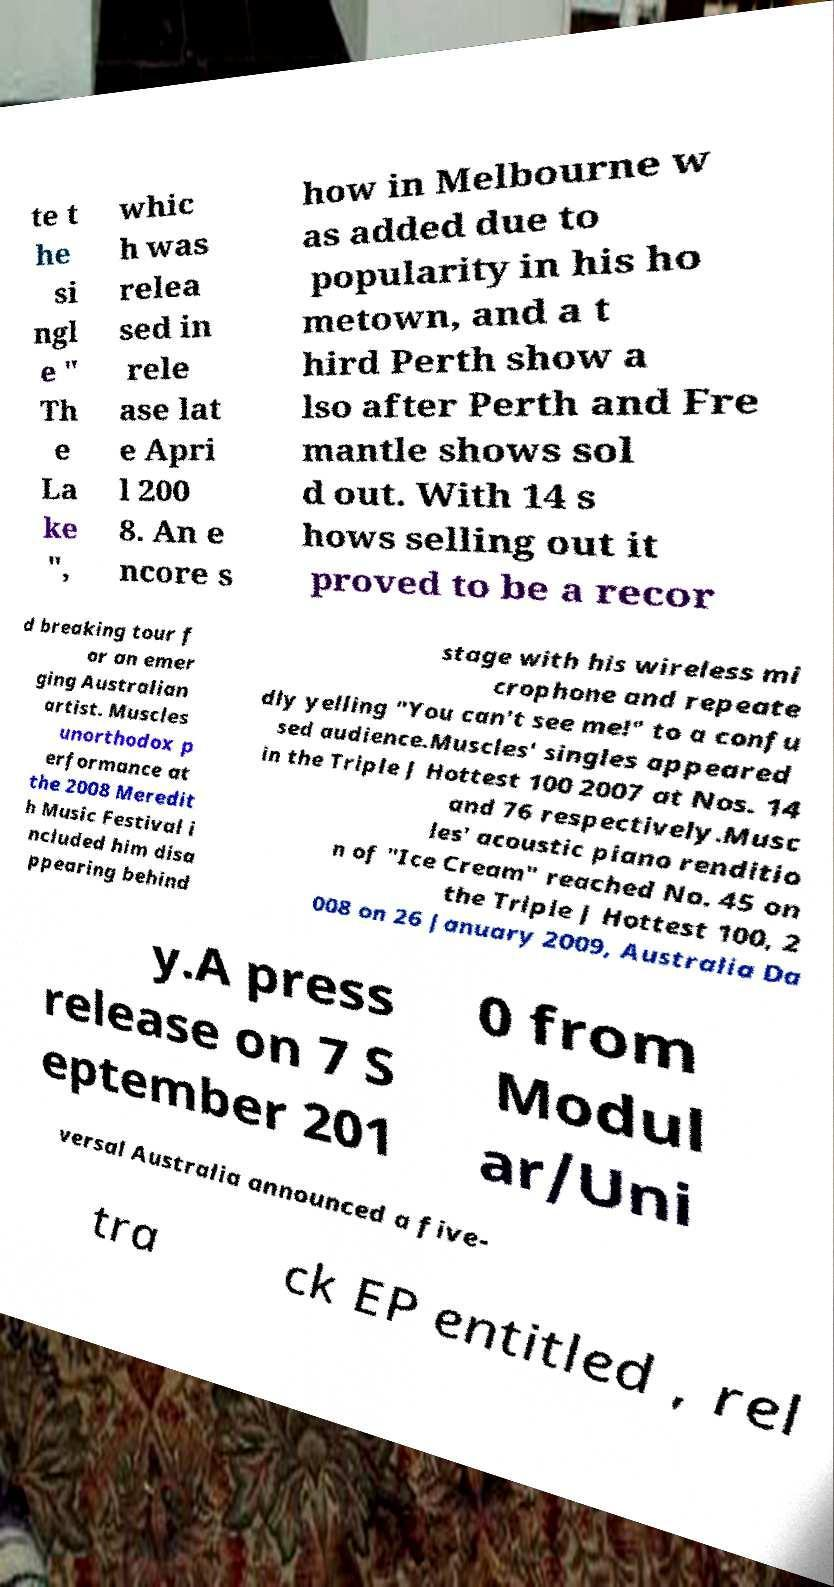I need the written content from this picture converted into text. Can you do that? te t he si ngl e " Th e La ke ", whic h was relea sed in rele ase lat e Apri l 200 8. An e ncore s how in Melbourne w as added due to popularity in his ho metown, and a t hird Perth show a lso after Perth and Fre mantle shows sol d out. With 14 s hows selling out it proved to be a recor d breaking tour f or an emer ging Australian artist. Muscles unorthodox p erformance at the 2008 Meredit h Music Festival i ncluded him disa ppearing behind stage with his wireless mi crophone and repeate dly yelling "You can't see me!" to a confu sed audience.Muscles' singles appeared in the Triple J Hottest 100 2007 at Nos. 14 and 76 respectively.Musc les' acoustic piano renditio n of "Ice Cream" reached No. 45 on the Triple J Hottest 100, 2 008 on 26 January 2009, Australia Da y.A press release on 7 S eptember 201 0 from Modul ar/Uni versal Australia announced a five- tra ck EP entitled , rel 